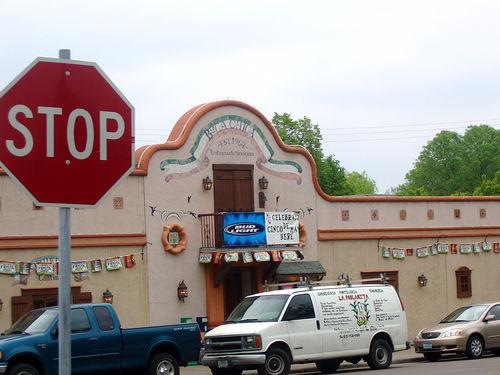What beer is being advertised?
Quick response, please. Bud light. What autos are in the photo?
Concise answer only. Truck van car. What is attached to the building on the roofing?
Answer briefly. Sign. What kind of street sign is in this photo?
Short answer required. Stop. 